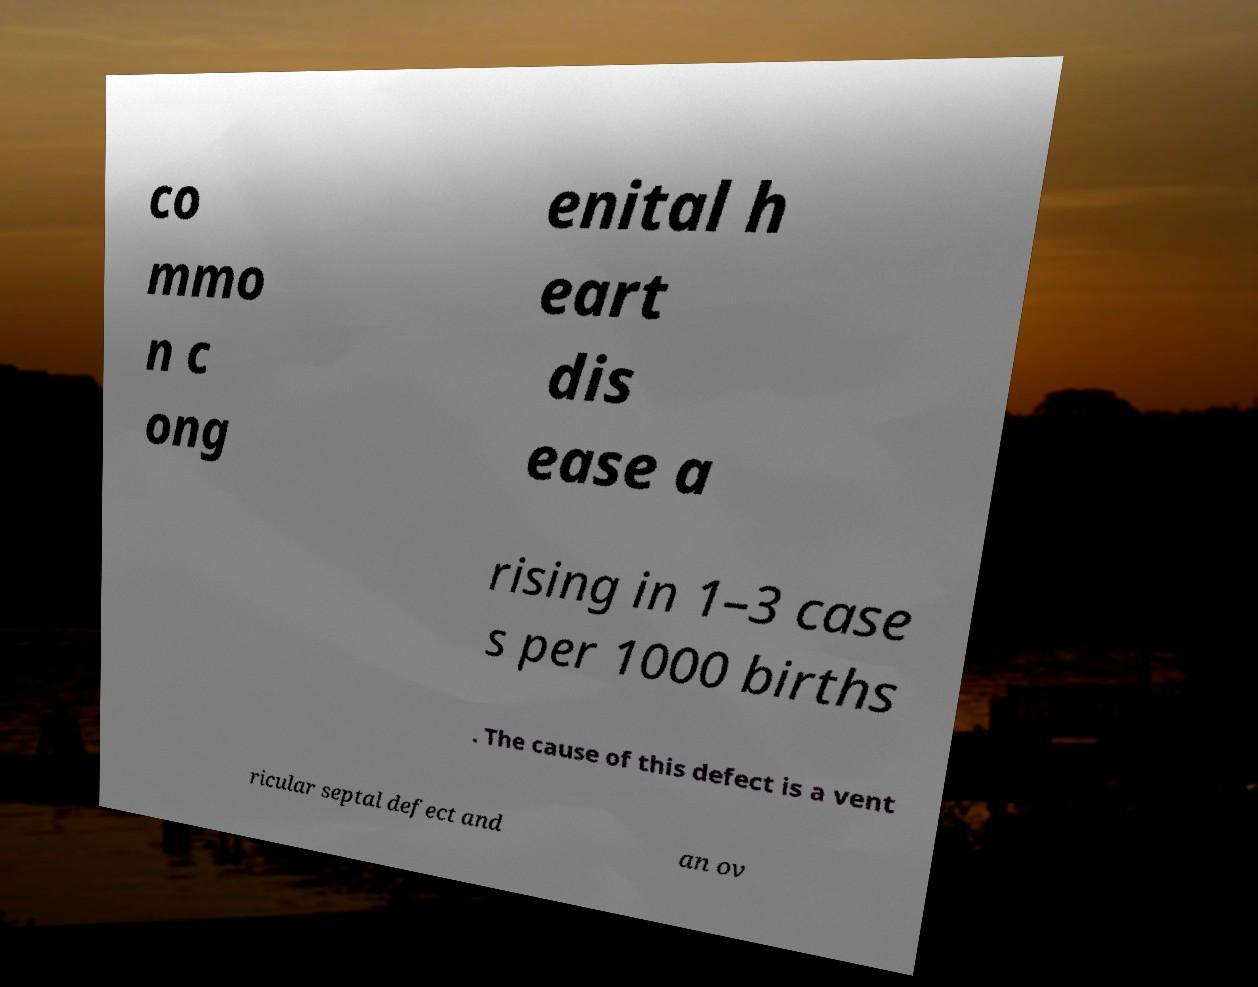Can you accurately transcribe the text from the provided image for me? co mmo n c ong enital h eart dis ease a rising in 1–3 case s per 1000 births . The cause of this defect is a vent ricular septal defect and an ov 